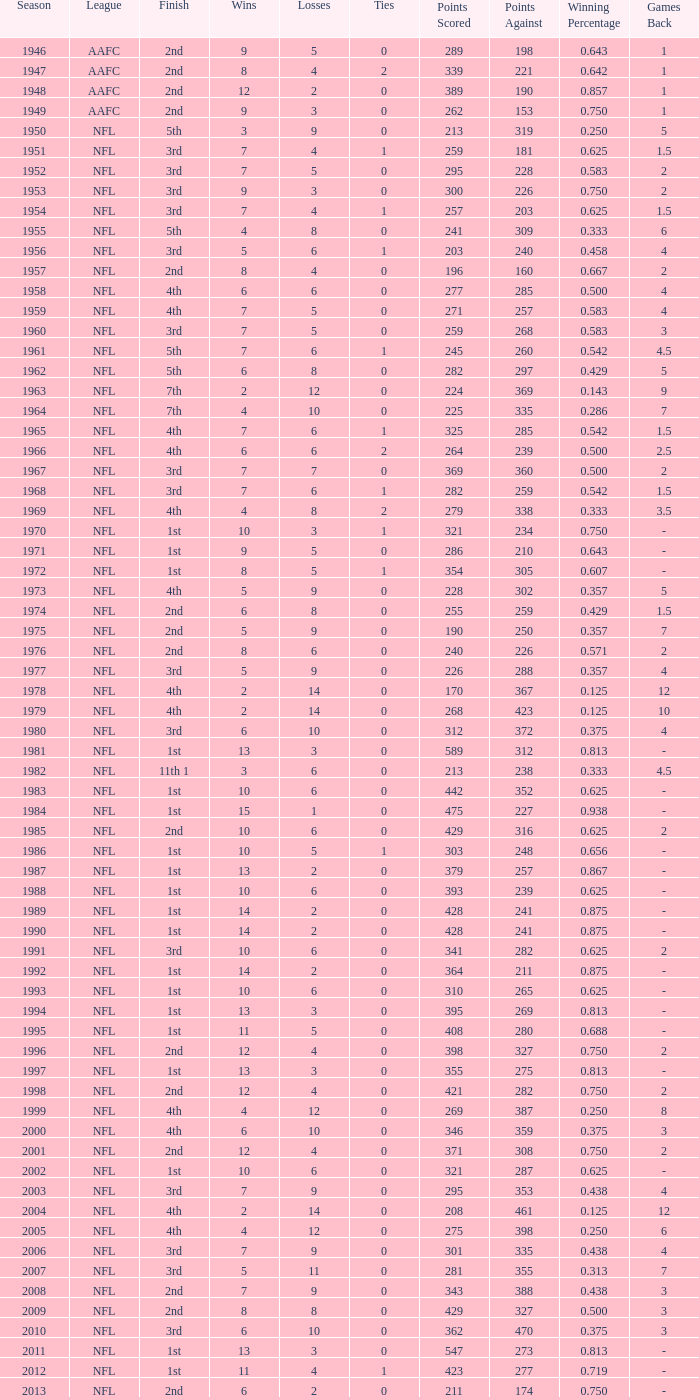What league had a finish of 2nd and 3 losses? AAFC. 